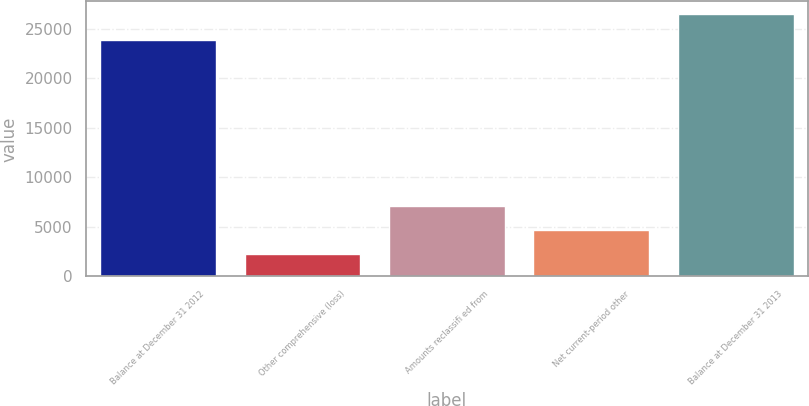<chart> <loc_0><loc_0><loc_500><loc_500><bar_chart><fcel>Balance at December 31 2012<fcel>Other comprehensive (loss)<fcel>Amounts reclassifi ed from<fcel>Net current-period other<fcel>Balance at December 31 2013<nl><fcel>23861<fcel>2237<fcel>7075<fcel>4656<fcel>26427<nl></chart> 